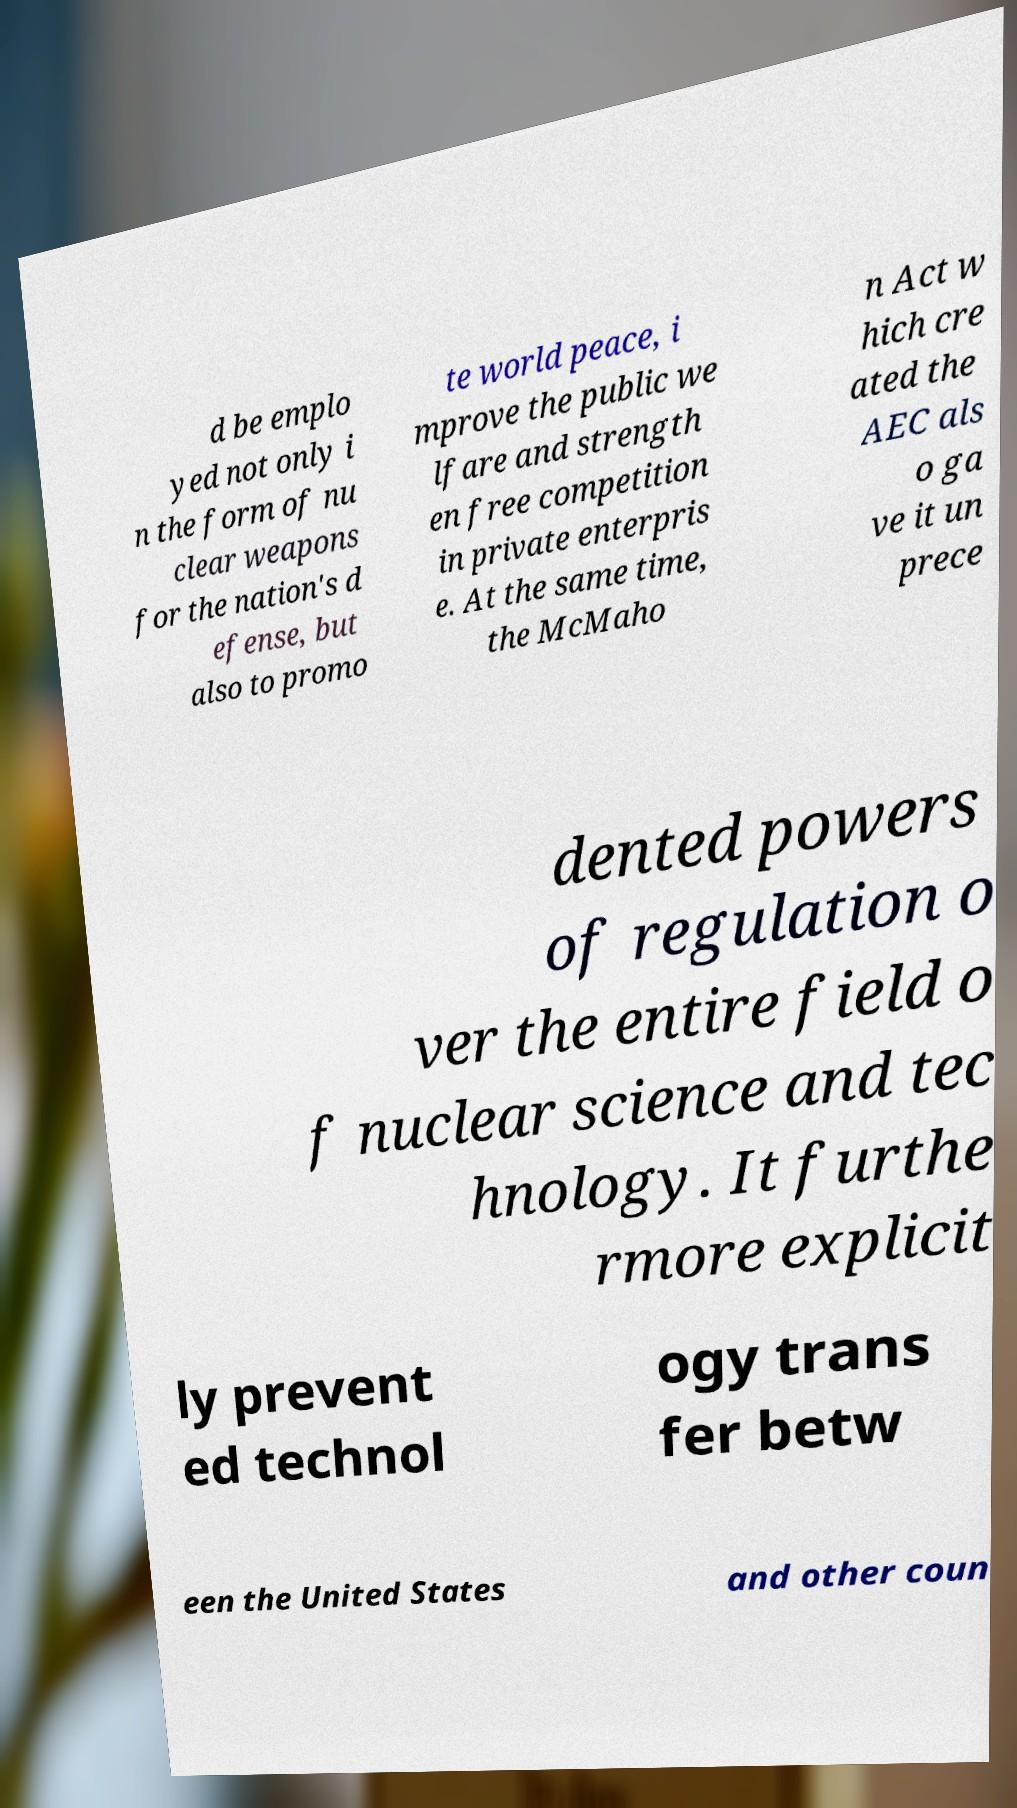Can you read and provide the text displayed in the image?This photo seems to have some interesting text. Can you extract and type it out for me? d be emplo yed not only i n the form of nu clear weapons for the nation's d efense, but also to promo te world peace, i mprove the public we lfare and strength en free competition in private enterpris e. At the same time, the McMaho n Act w hich cre ated the AEC als o ga ve it un prece dented powers of regulation o ver the entire field o f nuclear science and tec hnology. It furthe rmore explicit ly prevent ed technol ogy trans fer betw een the United States and other coun 